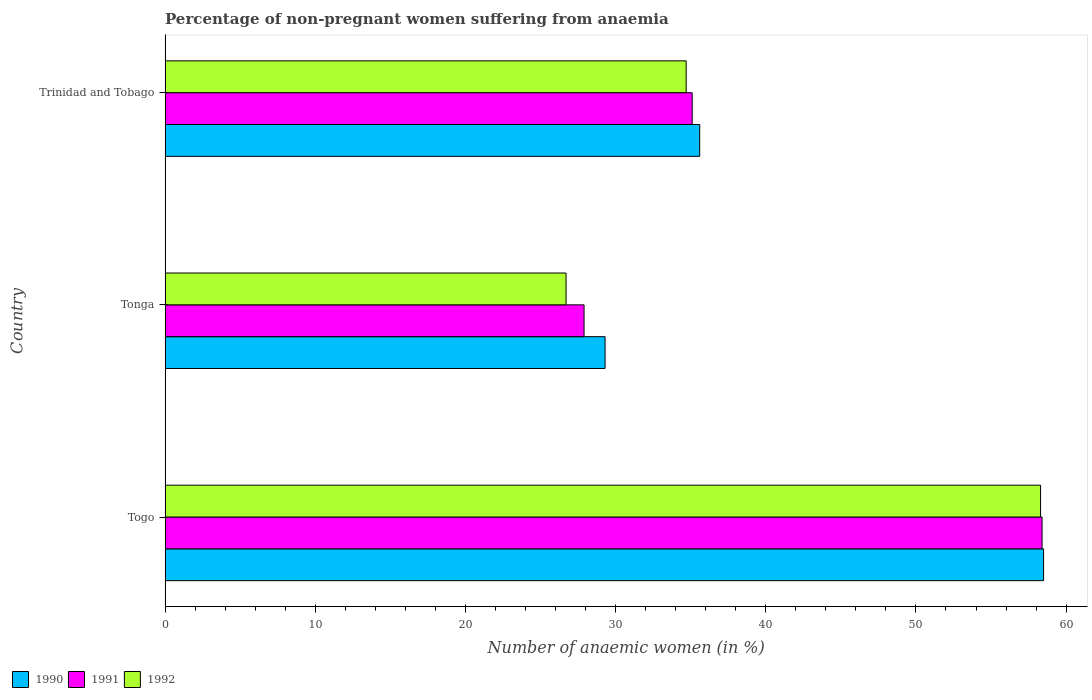How many different coloured bars are there?
Make the answer very short. 3. Are the number of bars on each tick of the Y-axis equal?
Provide a succinct answer. Yes. What is the label of the 2nd group of bars from the top?
Your answer should be very brief. Tonga. In how many cases, is the number of bars for a given country not equal to the number of legend labels?
Provide a short and direct response. 0. What is the percentage of non-pregnant women suffering from anaemia in 1990 in Togo?
Make the answer very short. 58.5. Across all countries, what is the maximum percentage of non-pregnant women suffering from anaemia in 1991?
Your response must be concise. 58.4. Across all countries, what is the minimum percentage of non-pregnant women suffering from anaemia in 1990?
Ensure brevity in your answer.  29.3. In which country was the percentage of non-pregnant women suffering from anaemia in 1992 maximum?
Provide a short and direct response. Togo. In which country was the percentage of non-pregnant women suffering from anaemia in 1991 minimum?
Your answer should be very brief. Tonga. What is the total percentage of non-pregnant women suffering from anaemia in 1990 in the graph?
Give a very brief answer. 123.4. What is the difference between the percentage of non-pregnant women suffering from anaemia in 1992 in Tonga and that in Trinidad and Tobago?
Make the answer very short. -8. What is the difference between the percentage of non-pregnant women suffering from anaemia in 1991 in Tonga and the percentage of non-pregnant women suffering from anaemia in 1990 in Togo?
Offer a terse response. -30.6. What is the average percentage of non-pregnant women suffering from anaemia in 1990 per country?
Give a very brief answer. 41.13. What is the difference between the percentage of non-pregnant women suffering from anaemia in 1992 and percentage of non-pregnant women suffering from anaemia in 1991 in Tonga?
Ensure brevity in your answer.  -1.2. In how many countries, is the percentage of non-pregnant women suffering from anaemia in 1990 greater than 32 %?
Your answer should be very brief. 2. What is the ratio of the percentage of non-pregnant women suffering from anaemia in 1991 in Togo to that in Tonga?
Give a very brief answer. 2.09. Is the percentage of non-pregnant women suffering from anaemia in 1991 in Togo less than that in Tonga?
Your answer should be very brief. No. Is the difference between the percentage of non-pregnant women suffering from anaemia in 1992 in Togo and Tonga greater than the difference between the percentage of non-pregnant women suffering from anaemia in 1991 in Togo and Tonga?
Your answer should be very brief. Yes. What is the difference between the highest and the second highest percentage of non-pregnant women suffering from anaemia in 1992?
Offer a terse response. 23.6. What is the difference between the highest and the lowest percentage of non-pregnant women suffering from anaemia in 1990?
Give a very brief answer. 29.2. In how many countries, is the percentage of non-pregnant women suffering from anaemia in 1992 greater than the average percentage of non-pregnant women suffering from anaemia in 1992 taken over all countries?
Ensure brevity in your answer.  1. Is the sum of the percentage of non-pregnant women suffering from anaemia in 1990 in Togo and Trinidad and Tobago greater than the maximum percentage of non-pregnant women suffering from anaemia in 1991 across all countries?
Offer a terse response. Yes. Is it the case that in every country, the sum of the percentage of non-pregnant women suffering from anaemia in 1990 and percentage of non-pregnant women suffering from anaemia in 1991 is greater than the percentage of non-pregnant women suffering from anaemia in 1992?
Give a very brief answer. Yes. How many bars are there?
Give a very brief answer. 9. How many countries are there in the graph?
Offer a very short reply. 3. What is the difference between two consecutive major ticks on the X-axis?
Offer a very short reply. 10. Does the graph contain any zero values?
Ensure brevity in your answer.  No. Does the graph contain grids?
Give a very brief answer. No. Where does the legend appear in the graph?
Your answer should be compact. Bottom left. How many legend labels are there?
Keep it short and to the point. 3. What is the title of the graph?
Offer a very short reply. Percentage of non-pregnant women suffering from anaemia. Does "1977" appear as one of the legend labels in the graph?
Offer a terse response. No. What is the label or title of the X-axis?
Ensure brevity in your answer.  Number of anaemic women (in %). What is the Number of anaemic women (in %) in 1990 in Togo?
Offer a terse response. 58.5. What is the Number of anaemic women (in %) of 1991 in Togo?
Ensure brevity in your answer.  58.4. What is the Number of anaemic women (in %) in 1992 in Togo?
Offer a very short reply. 58.3. What is the Number of anaemic women (in %) of 1990 in Tonga?
Your response must be concise. 29.3. What is the Number of anaemic women (in %) of 1991 in Tonga?
Keep it short and to the point. 27.9. What is the Number of anaemic women (in %) in 1992 in Tonga?
Offer a very short reply. 26.7. What is the Number of anaemic women (in %) in 1990 in Trinidad and Tobago?
Provide a short and direct response. 35.6. What is the Number of anaemic women (in %) in 1991 in Trinidad and Tobago?
Your answer should be compact. 35.1. What is the Number of anaemic women (in %) of 1992 in Trinidad and Tobago?
Your answer should be compact. 34.7. Across all countries, what is the maximum Number of anaemic women (in %) of 1990?
Offer a very short reply. 58.5. Across all countries, what is the maximum Number of anaemic women (in %) of 1991?
Provide a succinct answer. 58.4. Across all countries, what is the maximum Number of anaemic women (in %) of 1992?
Your response must be concise. 58.3. Across all countries, what is the minimum Number of anaemic women (in %) of 1990?
Offer a terse response. 29.3. Across all countries, what is the minimum Number of anaemic women (in %) of 1991?
Ensure brevity in your answer.  27.9. Across all countries, what is the minimum Number of anaemic women (in %) in 1992?
Keep it short and to the point. 26.7. What is the total Number of anaemic women (in %) in 1990 in the graph?
Make the answer very short. 123.4. What is the total Number of anaemic women (in %) of 1991 in the graph?
Provide a short and direct response. 121.4. What is the total Number of anaemic women (in %) of 1992 in the graph?
Provide a succinct answer. 119.7. What is the difference between the Number of anaemic women (in %) of 1990 in Togo and that in Tonga?
Keep it short and to the point. 29.2. What is the difference between the Number of anaemic women (in %) in 1991 in Togo and that in Tonga?
Make the answer very short. 30.5. What is the difference between the Number of anaemic women (in %) in 1992 in Togo and that in Tonga?
Provide a short and direct response. 31.6. What is the difference between the Number of anaemic women (in %) of 1990 in Togo and that in Trinidad and Tobago?
Make the answer very short. 22.9. What is the difference between the Number of anaemic women (in %) in 1991 in Togo and that in Trinidad and Tobago?
Your answer should be very brief. 23.3. What is the difference between the Number of anaemic women (in %) of 1992 in Togo and that in Trinidad and Tobago?
Make the answer very short. 23.6. What is the difference between the Number of anaemic women (in %) in 1991 in Tonga and that in Trinidad and Tobago?
Make the answer very short. -7.2. What is the difference between the Number of anaemic women (in %) in 1990 in Togo and the Number of anaemic women (in %) in 1991 in Tonga?
Provide a short and direct response. 30.6. What is the difference between the Number of anaemic women (in %) in 1990 in Togo and the Number of anaemic women (in %) in 1992 in Tonga?
Ensure brevity in your answer.  31.8. What is the difference between the Number of anaemic women (in %) in 1991 in Togo and the Number of anaemic women (in %) in 1992 in Tonga?
Keep it short and to the point. 31.7. What is the difference between the Number of anaemic women (in %) of 1990 in Togo and the Number of anaemic women (in %) of 1991 in Trinidad and Tobago?
Provide a succinct answer. 23.4. What is the difference between the Number of anaemic women (in %) in 1990 in Togo and the Number of anaemic women (in %) in 1992 in Trinidad and Tobago?
Your response must be concise. 23.8. What is the difference between the Number of anaemic women (in %) in 1991 in Togo and the Number of anaemic women (in %) in 1992 in Trinidad and Tobago?
Offer a terse response. 23.7. What is the difference between the Number of anaemic women (in %) of 1990 in Tonga and the Number of anaemic women (in %) of 1992 in Trinidad and Tobago?
Give a very brief answer. -5.4. What is the average Number of anaemic women (in %) of 1990 per country?
Your response must be concise. 41.13. What is the average Number of anaemic women (in %) of 1991 per country?
Give a very brief answer. 40.47. What is the average Number of anaemic women (in %) of 1992 per country?
Your answer should be very brief. 39.9. What is the difference between the Number of anaemic women (in %) of 1990 and Number of anaemic women (in %) of 1991 in Togo?
Your response must be concise. 0.1. What is the difference between the Number of anaemic women (in %) in 1990 and Number of anaemic women (in %) in 1992 in Togo?
Provide a short and direct response. 0.2. What is the difference between the Number of anaemic women (in %) in 1990 and Number of anaemic women (in %) in 1992 in Tonga?
Give a very brief answer. 2.6. What is the difference between the Number of anaemic women (in %) of 1991 and Number of anaemic women (in %) of 1992 in Tonga?
Keep it short and to the point. 1.2. What is the difference between the Number of anaemic women (in %) of 1990 and Number of anaemic women (in %) of 1991 in Trinidad and Tobago?
Your response must be concise. 0.5. What is the ratio of the Number of anaemic women (in %) in 1990 in Togo to that in Tonga?
Provide a short and direct response. 2. What is the ratio of the Number of anaemic women (in %) of 1991 in Togo to that in Tonga?
Your response must be concise. 2.09. What is the ratio of the Number of anaemic women (in %) of 1992 in Togo to that in Tonga?
Provide a short and direct response. 2.18. What is the ratio of the Number of anaemic women (in %) of 1990 in Togo to that in Trinidad and Tobago?
Your response must be concise. 1.64. What is the ratio of the Number of anaemic women (in %) in 1991 in Togo to that in Trinidad and Tobago?
Your answer should be compact. 1.66. What is the ratio of the Number of anaemic women (in %) of 1992 in Togo to that in Trinidad and Tobago?
Provide a succinct answer. 1.68. What is the ratio of the Number of anaemic women (in %) of 1990 in Tonga to that in Trinidad and Tobago?
Ensure brevity in your answer.  0.82. What is the ratio of the Number of anaemic women (in %) of 1991 in Tonga to that in Trinidad and Tobago?
Make the answer very short. 0.79. What is the ratio of the Number of anaemic women (in %) in 1992 in Tonga to that in Trinidad and Tobago?
Offer a terse response. 0.77. What is the difference between the highest and the second highest Number of anaemic women (in %) in 1990?
Ensure brevity in your answer.  22.9. What is the difference between the highest and the second highest Number of anaemic women (in %) of 1991?
Ensure brevity in your answer.  23.3. What is the difference between the highest and the second highest Number of anaemic women (in %) of 1992?
Your response must be concise. 23.6. What is the difference between the highest and the lowest Number of anaemic women (in %) in 1990?
Offer a very short reply. 29.2. What is the difference between the highest and the lowest Number of anaemic women (in %) of 1991?
Offer a terse response. 30.5. What is the difference between the highest and the lowest Number of anaemic women (in %) of 1992?
Give a very brief answer. 31.6. 